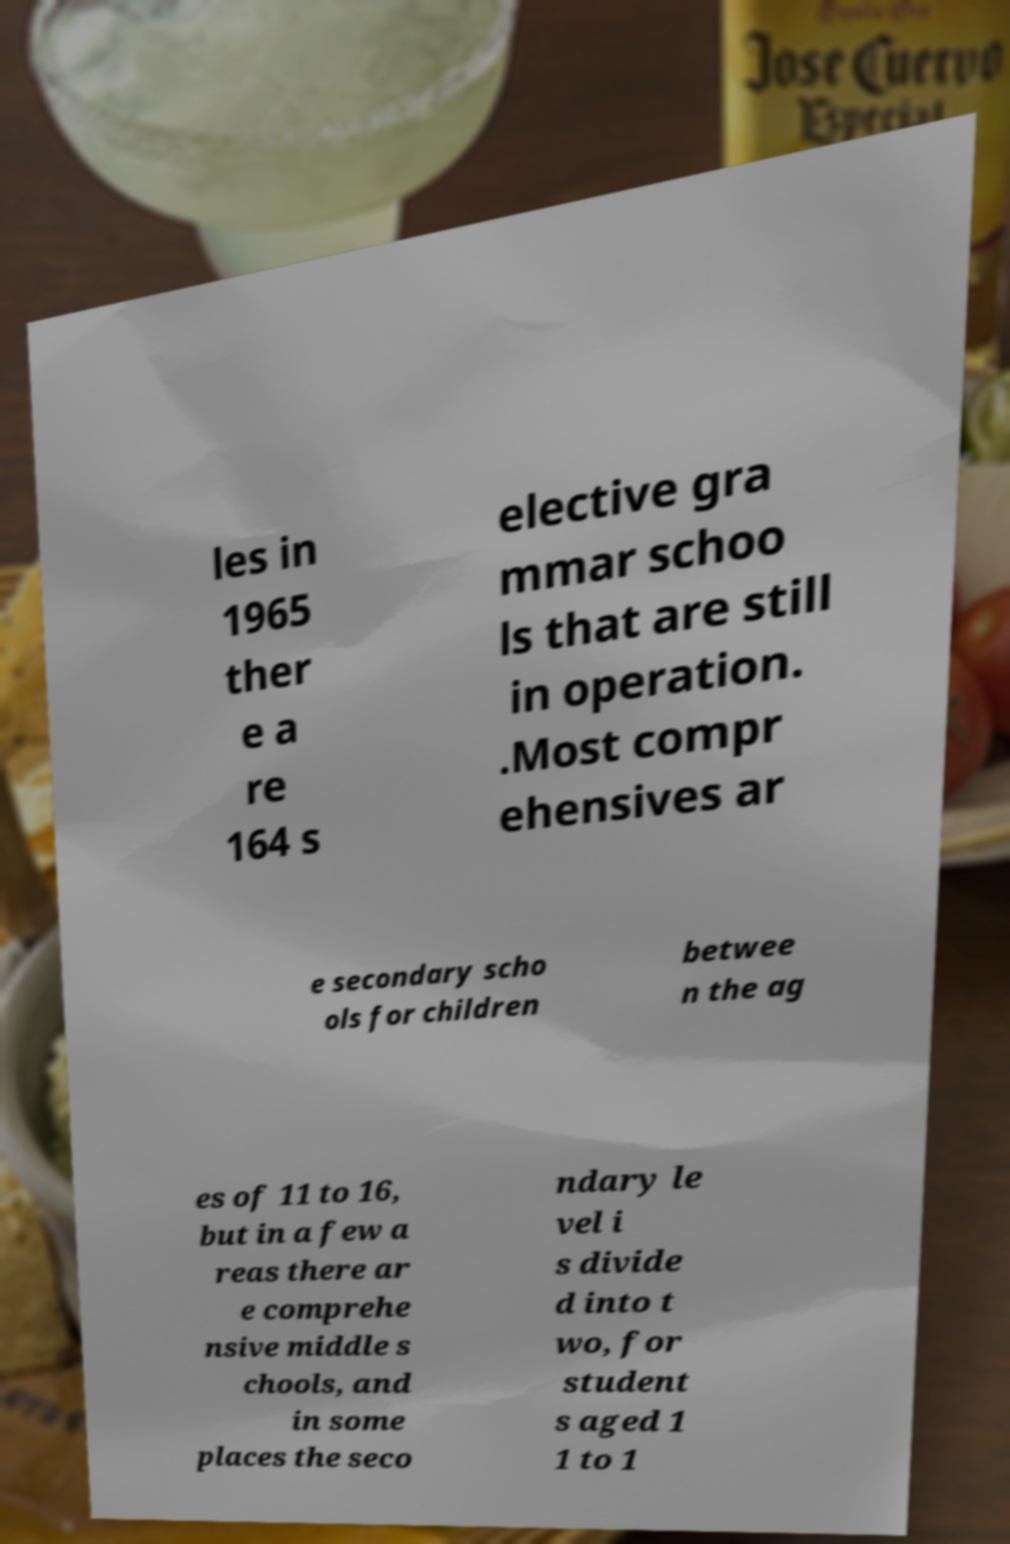Can you accurately transcribe the text from the provided image for me? les in 1965 ther e a re 164 s elective gra mmar schoo ls that are still in operation. .Most compr ehensives ar e secondary scho ols for children betwee n the ag es of 11 to 16, but in a few a reas there ar e comprehe nsive middle s chools, and in some places the seco ndary le vel i s divide d into t wo, for student s aged 1 1 to 1 